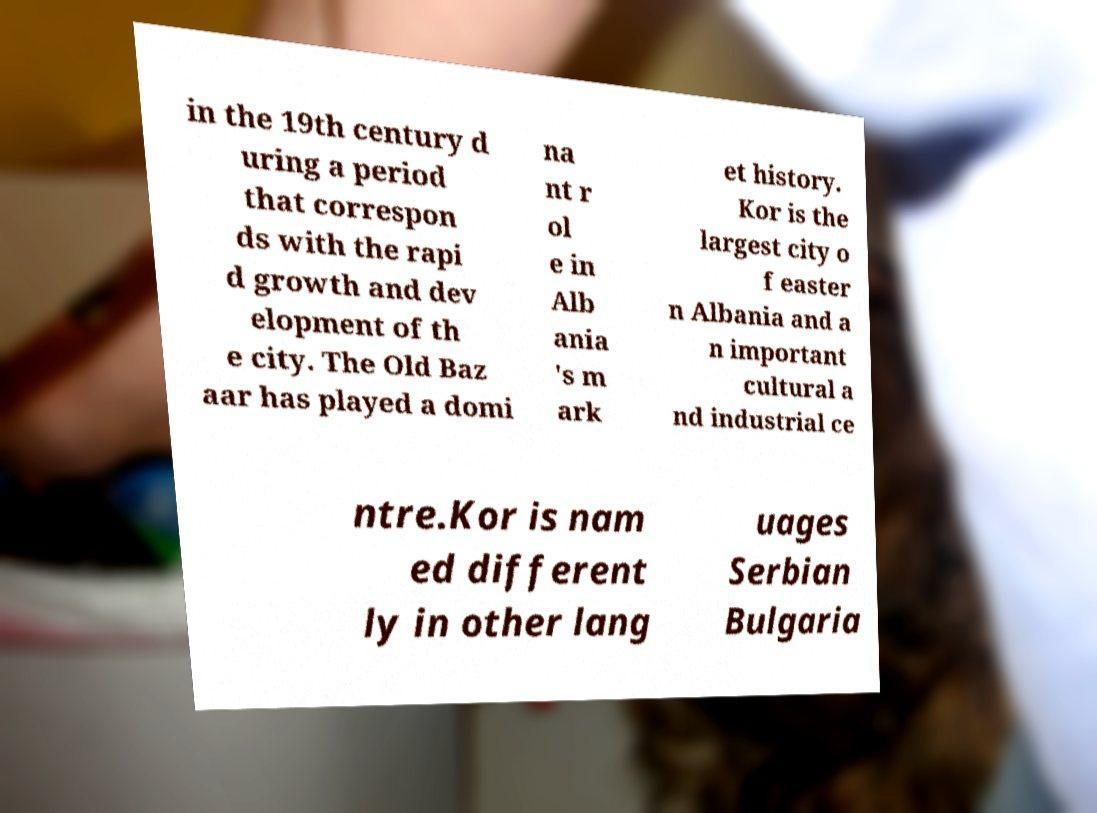Can you read and provide the text displayed in the image?This photo seems to have some interesting text. Can you extract and type it out for me? in the 19th century d uring a period that correspon ds with the rapi d growth and dev elopment of th e city. The Old Baz aar has played a domi na nt r ol e in Alb ania 's m ark et history. Kor is the largest city o f easter n Albania and a n important cultural a nd industrial ce ntre.Kor is nam ed different ly in other lang uages Serbian Bulgaria 